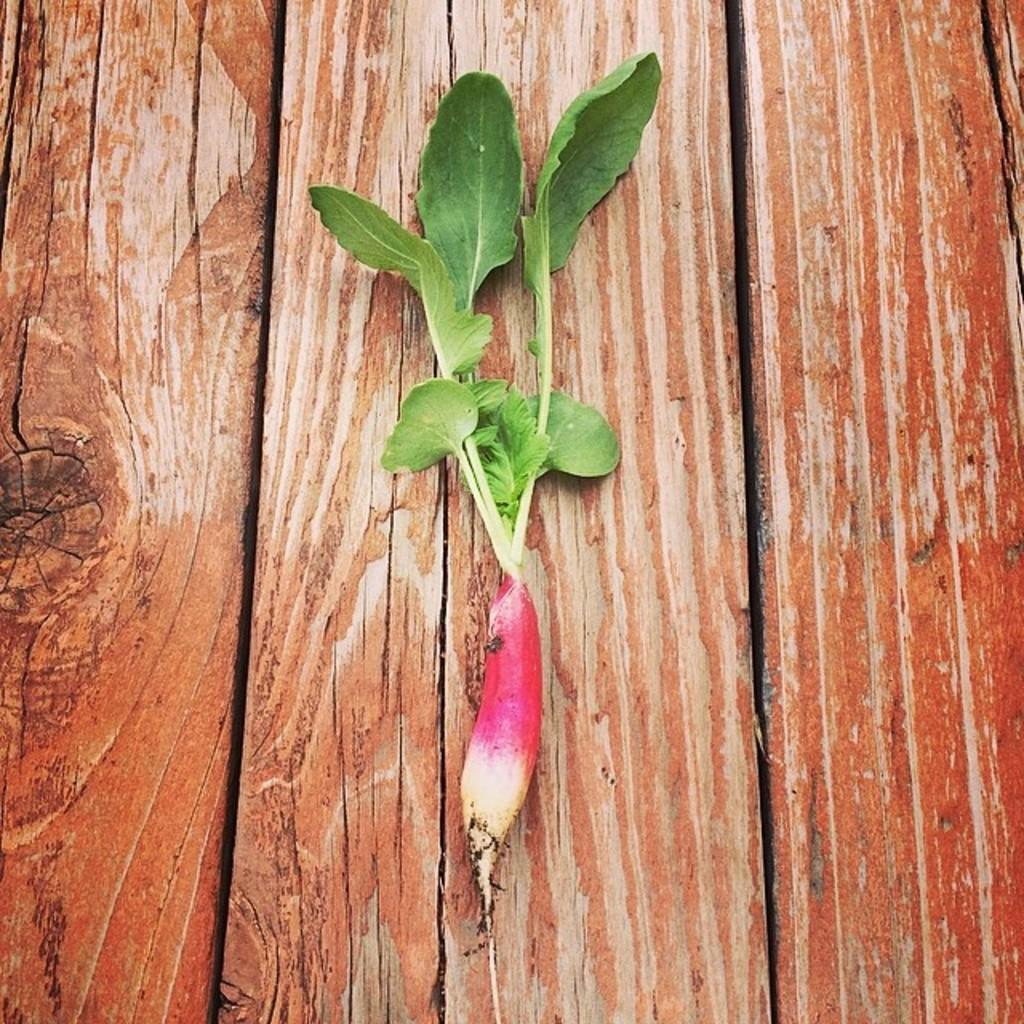What is on the table in the image? There is a plant on a table in the image. What is growing from the plant? There is a vegetable at the bottom of the plant. What color are the leaves of the plant? The leaves of the plant are green. Where is the glove located in the image? There is no glove present in the image. What type of hole can be seen in the plant? There is no hole present in the plant; it is a solid structure with leaves and a vegetable growing from it. 